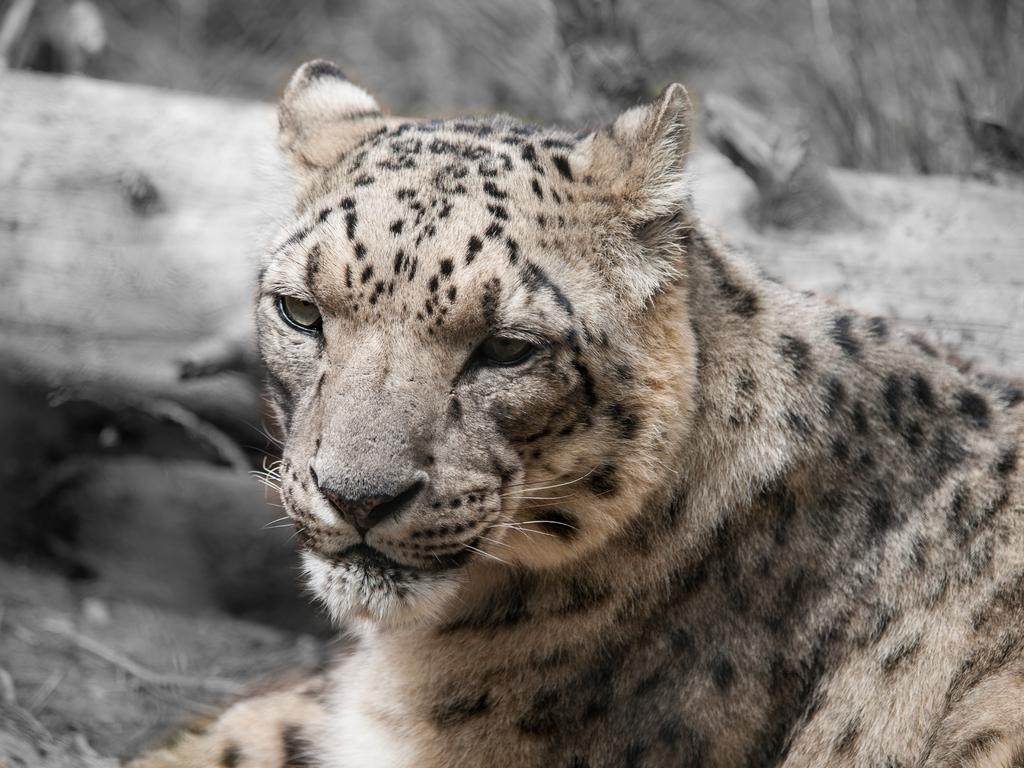What animal is the main subject of the image? There is a tiger in the image. How would you describe the clarity of the background in the image? The background of the image is not clear. What can be seen in the background of the image? There is a log visible in the background, and there are other objects present as well. How many fish are swimming around the tiger in the image? There are no fish present in the image; it features a tiger and a background with a log and other objects. What type of flowers can be seen growing near the tiger in the image? There are no flowers visible in the image; it features a tiger and a background with a log and other objects. 